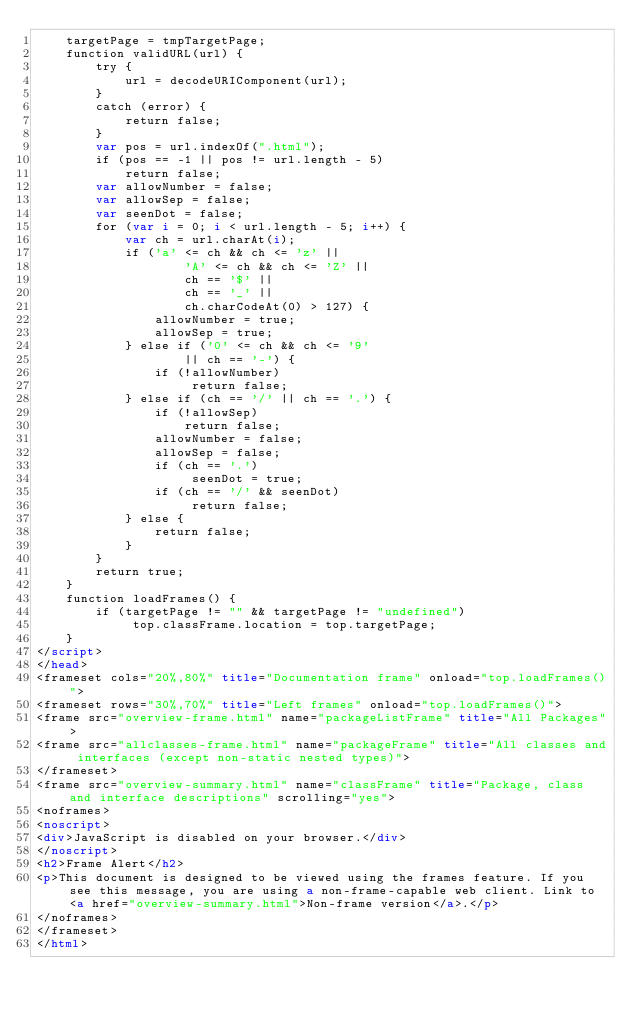<code> <loc_0><loc_0><loc_500><loc_500><_HTML_>    targetPage = tmpTargetPage;
    function validURL(url) {
        try {
            url = decodeURIComponent(url);
        }
        catch (error) {
            return false;
        }
        var pos = url.indexOf(".html");
        if (pos == -1 || pos != url.length - 5)
            return false;
        var allowNumber = false;
        var allowSep = false;
        var seenDot = false;
        for (var i = 0; i < url.length - 5; i++) {
            var ch = url.charAt(i);
            if ('a' <= ch && ch <= 'z' ||
                    'A' <= ch && ch <= 'Z' ||
                    ch == '$' ||
                    ch == '_' ||
                    ch.charCodeAt(0) > 127) {
                allowNumber = true;
                allowSep = true;
            } else if ('0' <= ch && ch <= '9'
                    || ch == '-') {
                if (!allowNumber)
                     return false;
            } else if (ch == '/' || ch == '.') {
                if (!allowSep)
                    return false;
                allowNumber = false;
                allowSep = false;
                if (ch == '.')
                     seenDot = true;
                if (ch == '/' && seenDot)
                     return false;
            } else {
                return false;
            }
        }
        return true;
    }
    function loadFrames() {
        if (targetPage != "" && targetPage != "undefined")
             top.classFrame.location = top.targetPage;
    }
</script>
</head>
<frameset cols="20%,80%" title="Documentation frame" onload="top.loadFrames()">
<frameset rows="30%,70%" title="Left frames" onload="top.loadFrames()">
<frame src="overview-frame.html" name="packageListFrame" title="All Packages">
<frame src="allclasses-frame.html" name="packageFrame" title="All classes and interfaces (except non-static nested types)">
</frameset>
<frame src="overview-summary.html" name="classFrame" title="Package, class and interface descriptions" scrolling="yes">
<noframes>
<noscript>
<div>JavaScript is disabled on your browser.</div>
</noscript>
<h2>Frame Alert</h2>
<p>This document is designed to be viewed using the frames feature. If you see this message, you are using a non-frame-capable web client. Link to <a href="overview-summary.html">Non-frame version</a>.</p>
</noframes>
</frameset>
</html>
</code> 